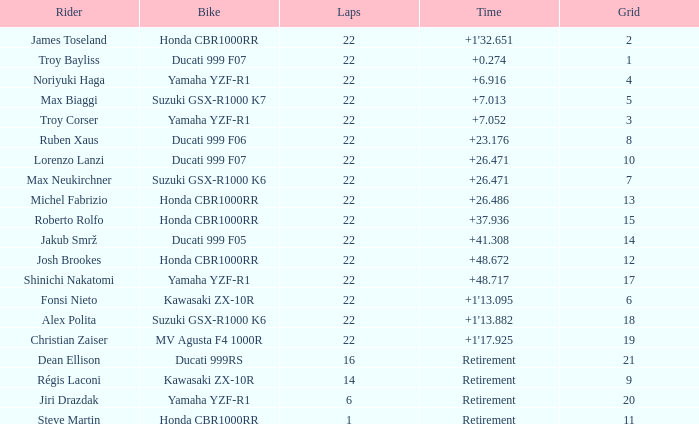What is the total grid number when Fonsi Nieto had more than 22 laps? 0.0. 